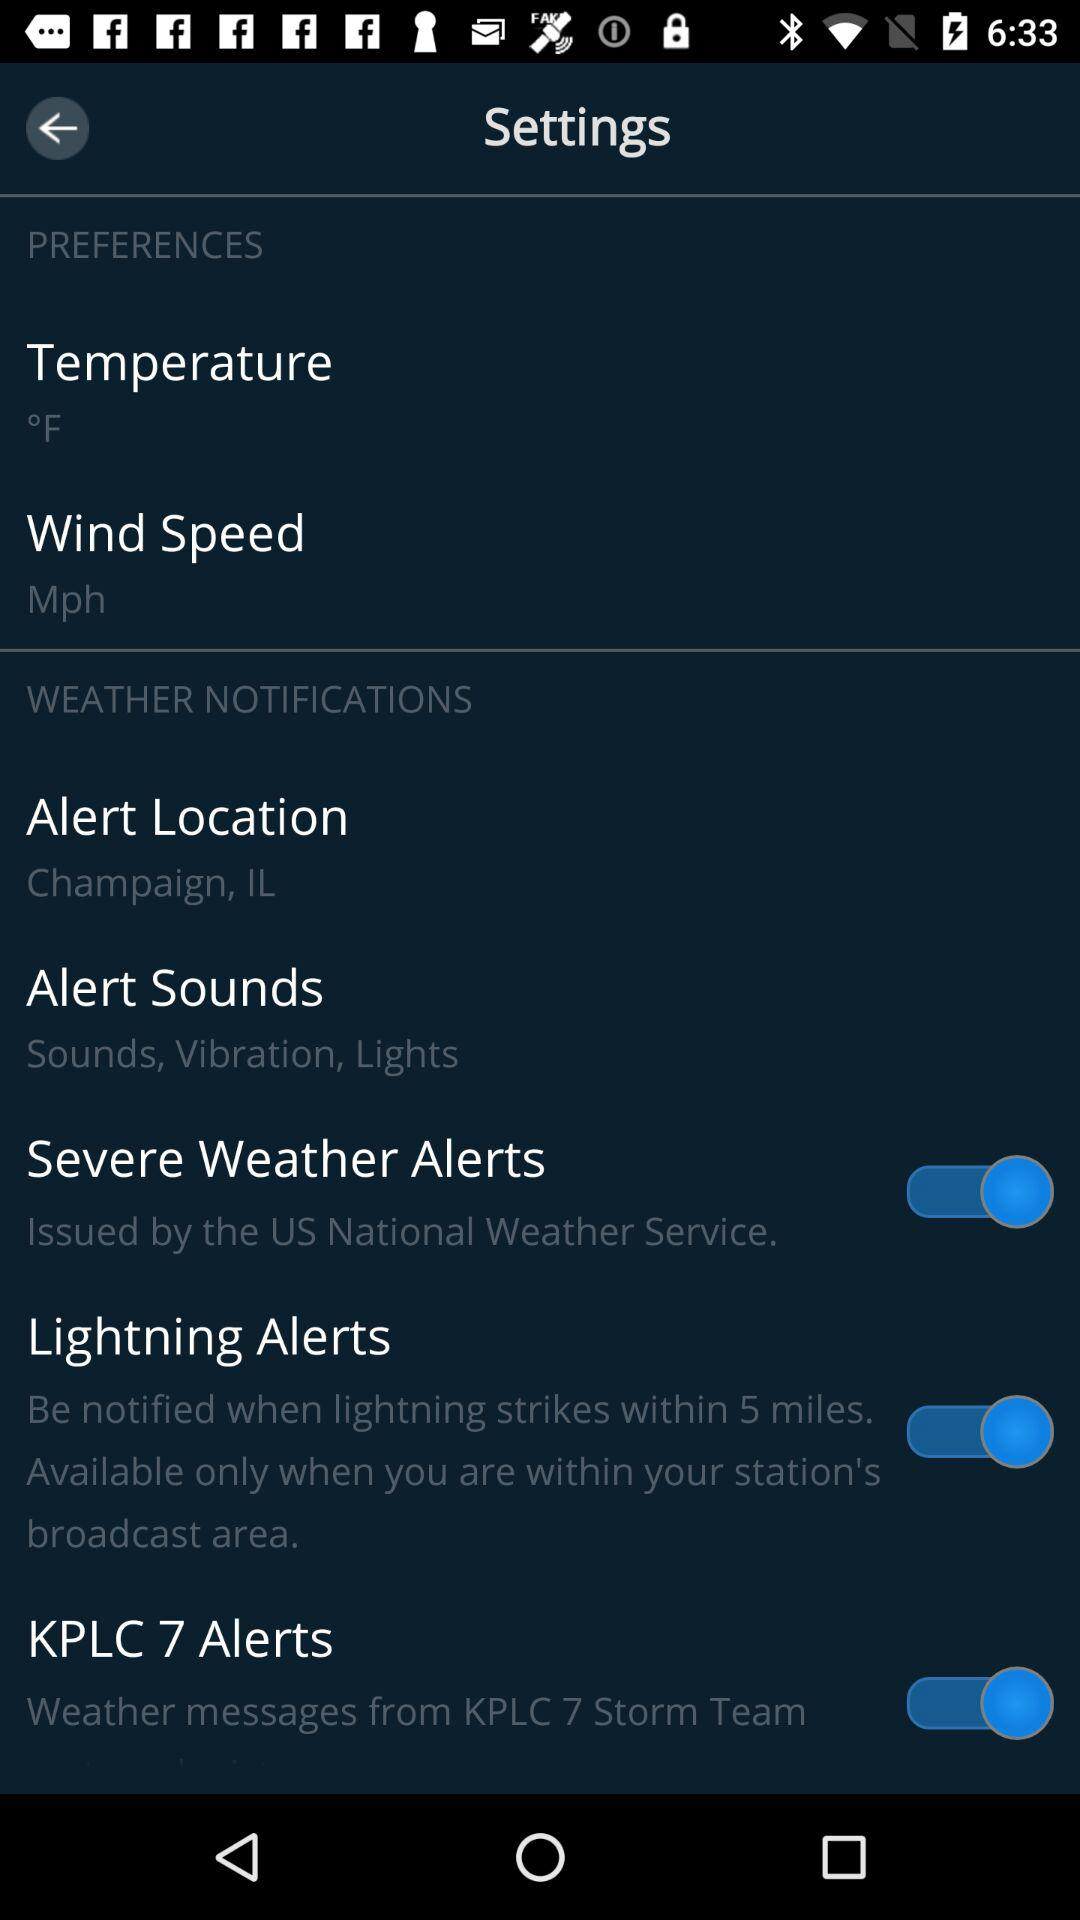What is the "Alert Location"? The alert location is "Champaign, IL". 